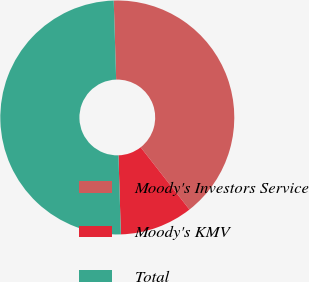Convert chart to OTSL. <chart><loc_0><loc_0><loc_500><loc_500><pie_chart><fcel>Moody's Investors Service<fcel>Moody's KMV<fcel>Total<nl><fcel>39.91%<fcel>10.09%<fcel>50.0%<nl></chart> 